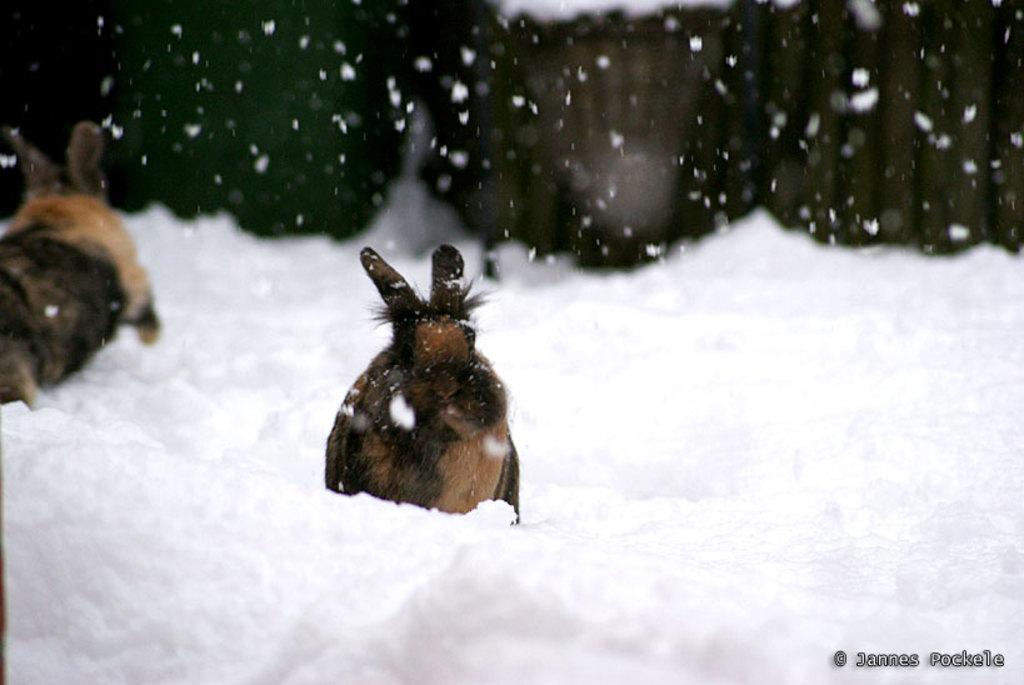Can you describe this image briefly? In this picture we can see two animals on snow and in the background it is blurry. 